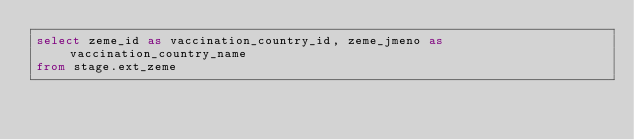Convert code to text. <code><loc_0><loc_0><loc_500><loc_500><_SQL_>select zeme_id as vaccination_country_id, zeme_jmeno as vaccination_country_name
from stage.ext_zeme
</code> 